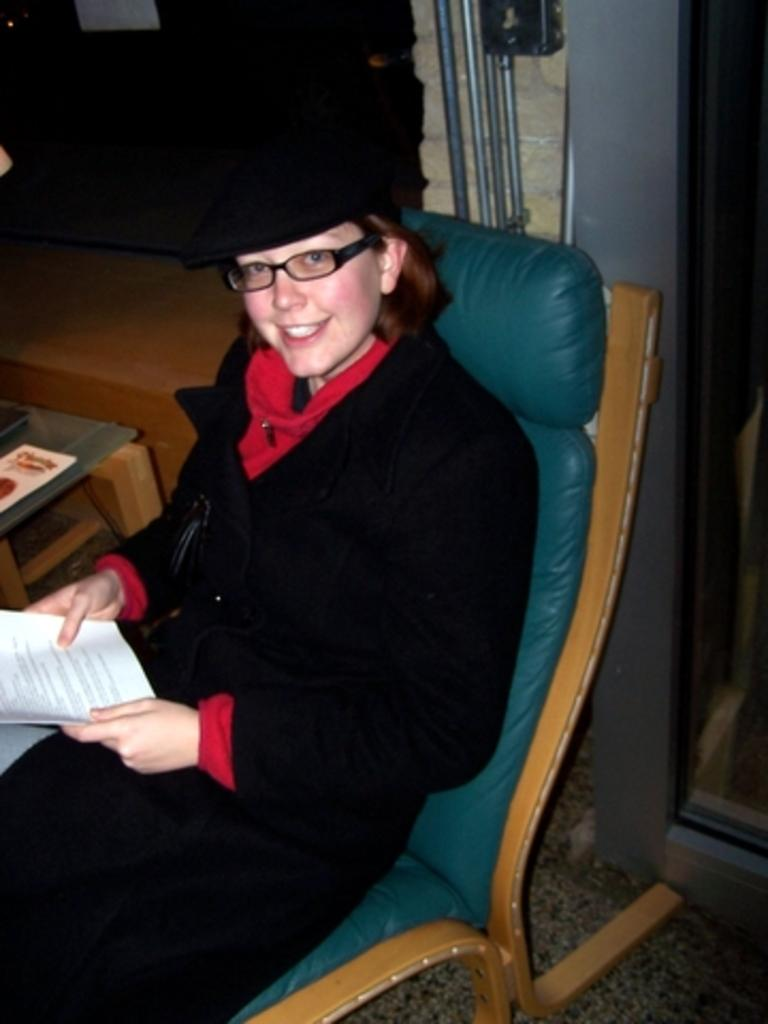Who is present in the image? There is a woman in the image. What is the woman doing in the image? The woman is sitting on a chair and holding papers in her hands. What can be seen to the left side of the image? There is a wooden table visible to the left side of the image. What is visible in the background of the image? There is a door visible in the background of the image. How many pizzas are being delivered by the plane in the image? There is no plane or pizzas present in the image. What type of house is visible in the image? There is no house visible in the image; only a door is visible in the background. 